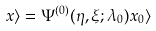Convert formula to latex. <formula><loc_0><loc_0><loc_500><loc_500>x \rangle = \Psi ^ { ( 0 ) } ( \eta , \xi ; \lambda _ { 0 } ) x _ { 0 } \rangle</formula> 